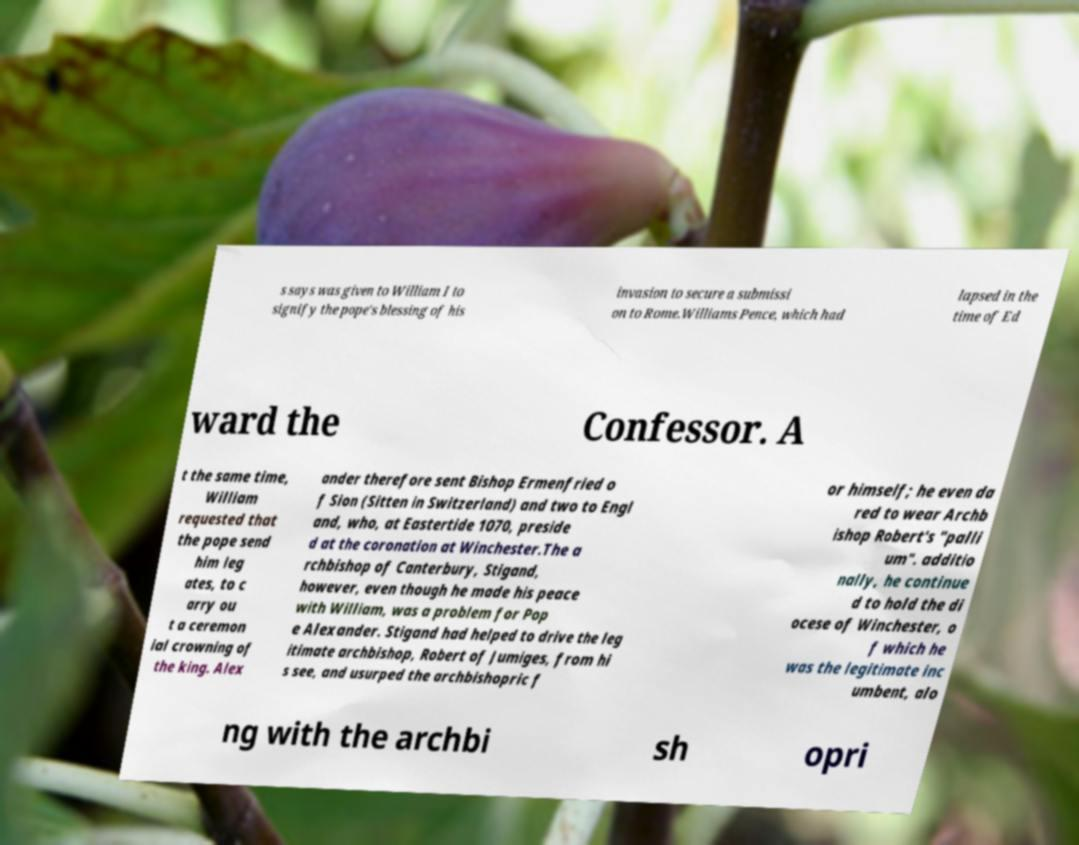Could you extract and type out the text from this image? s says was given to William I to signify the pope's blessing of his invasion to secure a submissi on to Rome.Williams Pence, which had lapsed in the time of Ed ward the Confessor. A t the same time, William requested that the pope send him leg ates, to c arry ou t a ceremon ial crowning of the king. Alex ander therefore sent Bishop Ermenfried o f Sion (Sitten in Switzerland) and two to Engl and, who, at Eastertide 1070, preside d at the coronation at Winchester.The a rchbishop of Canterbury, Stigand, however, even though he made his peace with William, was a problem for Pop e Alexander. Stigand had helped to drive the leg itimate archbishop, Robert of Jumiges, from hi s see, and usurped the archbishopric f or himself; he even da red to wear Archb ishop Robert's "palli um". additio nally, he continue d to hold the di ocese of Winchester, o f which he was the legitimate inc umbent, alo ng with the archbi sh opri 